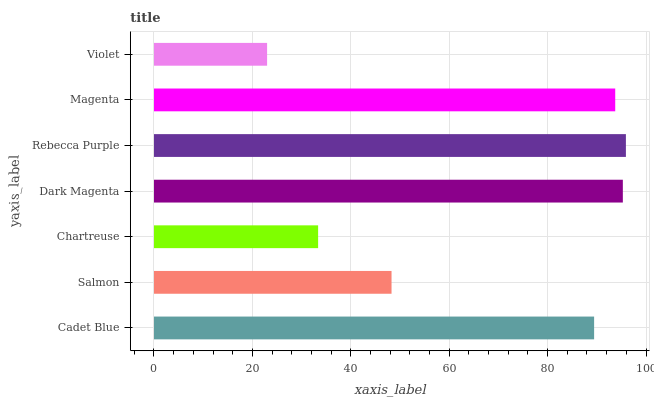Is Violet the minimum?
Answer yes or no. Yes. Is Rebecca Purple the maximum?
Answer yes or no. Yes. Is Salmon the minimum?
Answer yes or no. No. Is Salmon the maximum?
Answer yes or no. No. Is Cadet Blue greater than Salmon?
Answer yes or no. Yes. Is Salmon less than Cadet Blue?
Answer yes or no. Yes. Is Salmon greater than Cadet Blue?
Answer yes or no. No. Is Cadet Blue less than Salmon?
Answer yes or no. No. Is Cadet Blue the high median?
Answer yes or no. Yes. Is Cadet Blue the low median?
Answer yes or no. Yes. Is Violet the high median?
Answer yes or no. No. Is Magenta the low median?
Answer yes or no. No. 